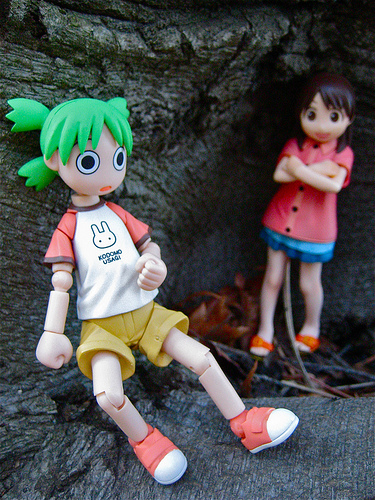<image>
Is there a toy on the tree? Yes. Looking at the image, I can see the toy is positioned on top of the tree, with the tree providing support. 